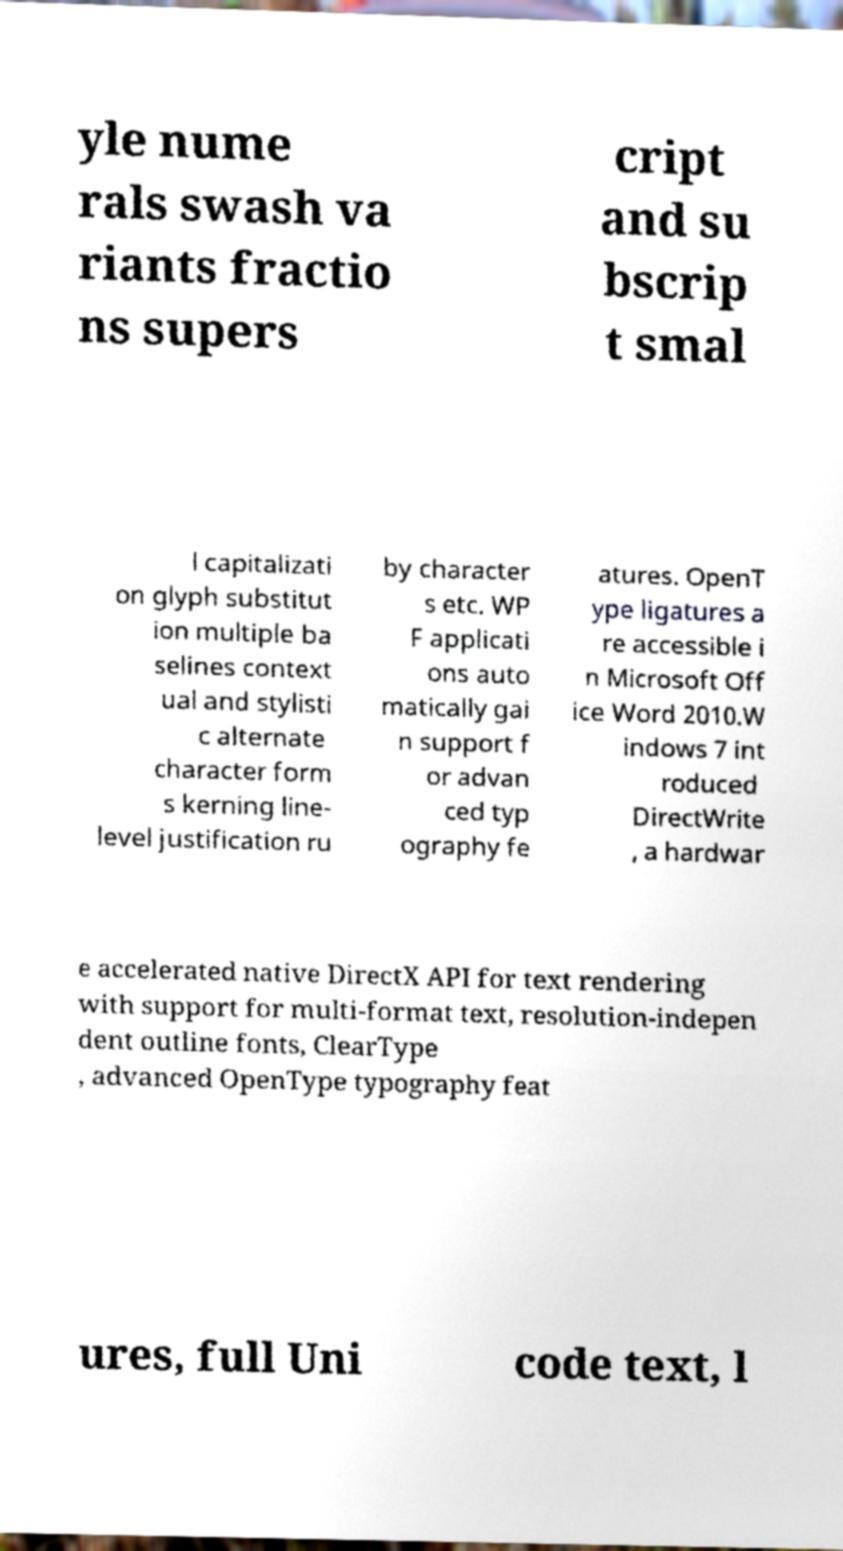I need the written content from this picture converted into text. Can you do that? yle nume rals swash va riants fractio ns supers cript and su bscrip t smal l capitalizati on glyph substitut ion multiple ba selines context ual and stylisti c alternate character form s kerning line- level justification ru by character s etc. WP F applicati ons auto matically gai n support f or advan ced typ ography fe atures. OpenT ype ligatures a re accessible i n Microsoft Off ice Word 2010.W indows 7 int roduced DirectWrite , a hardwar e accelerated native DirectX API for text rendering with support for multi-format text, resolution-indepen dent outline fonts, ClearType , advanced OpenType typography feat ures, full Uni code text, l 